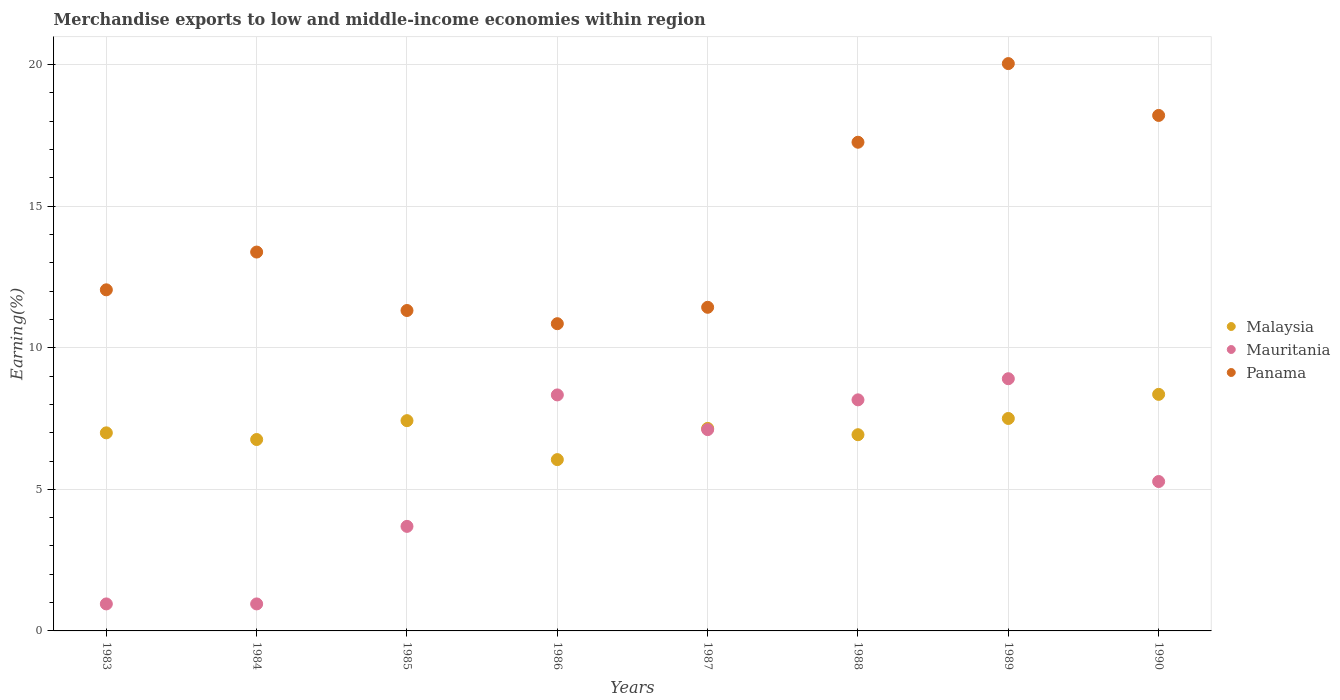How many different coloured dotlines are there?
Offer a very short reply. 3. What is the percentage of amount earned from merchandise exports in Panama in 1985?
Offer a terse response. 11.32. Across all years, what is the maximum percentage of amount earned from merchandise exports in Mauritania?
Your response must be concise. 8.91. Across all years, what is the minimum percentage of amount earned from merchandise exports in Malaysia?
Your response must be concise. 6.05. In which year was the percentage of amount earned from merchandise exports in Malaysia maximum?
Your answer should be compact. 1990. What is the total percentage of amount earned from merchandise exports in Malaysia in the graph?
Provide a short and direct response. 57.17. What is the difference between the percentage of amount earned from merchandise exports in Mauritania in 1983 and that in 1985?
Keep it short and to the point. -2.74. What is the difference between the percentage of amount earned from merchandise exports in Malaysia in 1985 and the percentage of amount earned from merchandise exports in Mauritania in 1989?
Your answer should be compact. -1.48. What is the average percentage of amount earned from merchandise exports in Malaysia per year?
Give a very brief answer. 7.15. In the year 1986, what is the difference between the percentage of amount earned from merchandise exports in Mauritania and percentage of amount earned from merchandise exports in Panama?
Provide a short and direct response. -2.52. What is the ratio of the percentage of amount earned from merchandise exports in Mauritania in 1983 to that in 1984?
Your response must be concise. 1. Is the difference between the percentage of amount earned from merchandise exports in Mauritania in 1984 and 1988 greater than the difference between the percentage of amount earned from merchandise exports in Panama in 1984 and 1988?
Make the answer very short. No. What is the difference between the highest and the second highest percentage of amount earned from merchandise exports in Panama?
Offer a very short reply. 1.83. What is the difference between the highest and the lowest percentage of amount earned from merchandise exports in Panama?
Offer a terse response. 9.19. Is the sum of the percentage of amount earned from merchandise exports in Malaysia in 1983 and 1990 greater than the maximum percentage of amount earned from merchandise exports in Panama across all years?
Provide a short and direct response. No. Is it the case that in every year, the sum of the percentage of amount earned from merchandise exports in Malaysia and percentage of amount earned from merchandise exports in Mauritania  is greater than the percentage of amount earned from merchandise exports in Panama?
Make the answer very short. No. Does the percentage of amount earned from merchandise exports in Malaysia monotonically increase over the years?
Offer a terse response. No. Is the percentage of amount earned from merchandise exports in Malaysia strictly greater than the percentage of amount earned from merchandise exports in Panama over the years?
Offer a terse response. No. What is the difference between two consecutive major ticks on the Y-axis?
Keep it short and to the point. 5. Are the values on the major ticks of Y-axis written in scientific E-notation?
Provide a short and direct response. No. Does the graph contain grids?
Your answer should be very brief. Yes. How many legend labels are there?
Ensure brevity in your answer.  3. How are the legend labels stacked?
Keep it short and to the point. Vertical. What is the title of the graph?
Keep it short and to the point. Merchandise exports to low and middle-income economies within region. Does "Micronesia" appear as one of the legend labels in the graph?
Offer a very short reply. No. What is the label or title of the X-axis?
Your answer should be very brief. Years. What is the label or title of the Y-axis?
Make the answer very short. Earning(%). What is the Earning(%) of Malaysia in 1983?
Keep it short and to the point. 7. What is the Earning(%) in Mauritania in 1983?
Provide a short and direct response. 0.95. What is the Earning(%) of Panama in 1983?
Your answer should be compact. 12.05. What is the Earning(%) in Malaysia in 1984?
Your answer should be compact. 6.76. What is the Earning(%) in Mauritania in 1984?
Provide a short and direct response. 0.95. What is the Earning(%) of Panama in 1984?
Offer a terse response. 13.38. What is the Earning(%) of Malaysia in 1985?
Provide a short and direct response. 7.43. What is the Earning(%) in Mauritania in 1985?
Give a very brief answer. 3.69. What is the Earning(%) of Panama in 1985?
Make the answer very short. 11.32. What is the Earning(%) of Malaysia in 1986?
Provide a succinct answer. 6.05. What is the Earning(%) of Mauritania in 1986?
Provide a short and direct response. 8.33. What is the Earning(%) in Panama in 1986?
Provide a succinct answer. 10.85. What is the Earning(%) in Malaysia in 1987?
Your answer should be compact. 7.15. What is the Earning(%) of Mauritania in 1987?
Offer a terse response. 7.11. What is the Earning(%) in Panama in 1987?
Make the answer very short. 11.43. What is the Earning(%) of Malaysia in 1988?
Make the answer very short. 6.93. What is the Earning(%) in Mauritania in 1988?
Offer a very short reply. 8.16. What is the Earning(%) of Panama in 1988?
Provide a succinct answer. 17.26. What is the Earning(%) in Malaysia in 1989?
Your response must be concise. 7.5. What is the Earning(%) of Mauritania in 1989?
Offer a very short reply. 8.91. What is the Earning(%) of Panama in 1989?
Provide a short and direct response. 20.04. What is the Earning(%) in Malaysia in 1990?
Keep it short and to the point. 8.35. What is the Earning(%) of Mauritania in 1990?
Keep it short and to the point. 5.28. What is the Earning(%) in Panama in 1990?
Keep it short and to the point. 18.2. Across all years, what is the maximum Earning(%) of Malaysia?
Keep it short and to the point. 8.35. Across all years, what is the maximum Earning(%) in Mauritania?
Keep it short and to the point. 8.91. Across all years, what is the maximum Earning(%) in Panama?
Ensure brevity in your answer.  20.04. Across all years, what is the minimum Earning(%) in Malaysia?
Provide a succinct answer. 6.05. Across all years, what is the minimum Earning(%) of Mauritania?
Give a very brief answer. 0.95. Across all years, what is the minimum Earning(%) of Panama?
Your answer should be compact. 10.85. What is the total Earning(%) in Malaysia in the graph?
Provide a succinct answer. 57.17. What is the total Earning(%) in Mauritania in the graph?
Provide a short and direct response. 43.39. What is the total Earning(%) in Panama in the graph?
Provide a succinct answer. 114.52. What is the difference between the Earning(%) in Malaysia in 1983 and that in 1984?
Offer a terse response. 0.24. What is the difference between the Earning(%) of Panama in 1983 and that in 1984?
Offer a very short reply. -1.33. What is the difference between the Earning(%) in Malaysia in 1983 and that in 1985?
Keep it short and to the point. -0.43. What is the difference between the Earning(%) of Mauritania in 1983 and that in 1985?
Your response must be concise. -2.74. What is the difference between the Earning(%) in Panama in 1983 and that in 1985?
Make the answer very short. 0.73. What is the difference between the Earning(%) of Malaysia in 1983 and that in 1986?
Keep it short and to the point. 0.95. What is the difference between the Earning(%) in Mauritania in 1983 and that in 1986?
Offer a terse response. -7.38. What is the difference between the Earning(%) of Panama in 1983 and that in 1986?
Ensure brevity in your answer.  1.2. What is the difference between the Earning(%) of Malaysia in 1983 and that in 1987?
Make the answer very short. -0.16. What is the difference between the Earning(%) of Mauritania in 1983 and that in 1987?
Your answer should be very brief. -6.16. What is the difference between the Earning(%) in Panama in 1983 and that in 1987?
Offer a very short reply. 0.62. What is the difference between the Earning(%) in Malaysia in 1983 and that in 1988?
Your response must be concise. 0.07. What is the difference between the Earning(%) of Mauritania in 1983 and that in 1988?
Offer a terse response. -7.21. What is the difference between the Earning(%) in Panama in 1983 and that in 1988?
Make the answer very short. -5.21. What is the difference between the Earning(%) of Malaysia in 1983 and that in 1989?
Ensure brevity in your answer.  -0.51. What is the difference between the Earning(%) of Mauritania in 1983 and that in 1989?
Your answer should be very brief. -7.95. What is the difference between the Earning(%) in Panama in 1983 and that in 1989?
Provide a succinct answer. -7.99. What is the difference between the Earning(%) of Malaysia in 1983 and that in 1990?
Give a very brief answer. -1.36. What is the difference between the Earning(%) of Mauritania in 1983 and that in 1990?
Your response must be concise. -4.32. What is the difference between the Earning(%) of Panama in 1983 and that in 1990?
Your response must be concise. -6.16. What is the difference between the Earning(%) in Malaysia in 1984 and that in 1985?
Ensure brevity in your answer.  -0.67. What is the difference between the Earning(%) of Mauritania in 1984 and that in 1985?
Ensure brevity in your answer.  -2.74. What is the difference between the Earning(%) in Panama in 1984 and that in 1985?
Provide a succinct answer. 2.06. What is the difference between the Earning(%) of Malaysia in 1984 and that in 1986?
Offer a terse response. 0.71. What is the difference between the Earning(%) in Mauritania in 1984 and that in 1986?
Your answer should be compact. -7.38. What is the difference between the Earning(%) of Panama in 1984 and that in 1986?
Your answer should be compact. 2.53. What is the difference between the Earning(%) of Malaysia in 1984 and that in 1987?
Give a very brief answer. -0.39. What is the difference between the Earning(%) of Mauritania in 1984 and that in 1987?
Provide a short and direct response. -6.16. What is the difference between the Earning(%) in Panama in 1984 and that in 1987?
Your answer should be compact. 1.95. What is the difference between the Earning(%) in Malaysia in 1984 and that in 1988?
Give a very brief answer. -0.17. What is the difference between the Earning(%) in Mauritania in 1984 and that in 1988?
Keep it short and to the point. -7.21. What is the difference between the Earning(%) in Panama in 1984 and that in 1988?
Your answer should be very brief. -3.88. What is the difference between the Earning(%) in Malaysia in 1984 and that in 1989?
Provide a succinct answer. -0.74. What is the difference between the Earning(%) of Mauritania in 1984 and that in 1989?
Your answer should be compact. -7.95. What is the difference between the Earning(%) in Panama in 1984 and that in 1989?
Offer a terse response. -6.66. What is the difference between the Earning(%) of Malaysia in 1984 and that in 1990?
Offer a very short reply. -1.59. What is the difference between the Earning(%) of Mauritania in 1984 and that in 1990?
Provide a short and direct response. -4.32. What is the difference between the Earning(%) in Panama in 1984 and that in 1990?
Provide a short and direct response. -4.83. What is the difference between the Earning(%) of Malaysia in 1985 and that in 1986?
Give a very brief answer. 1.38. What is the difference between the Earning(%) in Mauritania in 1985 and that in 1986?
Offer a very short reply. -4.64. What is the difference between the Earning(%) in Panama in 1985 and that in 1986?
Offer a very short reply. 0.47. What is the difference between the Earning(%) of Malaysia in 1985 and that in 1987?
Make the answer very short. 0.27. What is the difference between the Earning(%) of Mauritania in 1985 and that in 1987?
Provide a succinct answer. -3.42. What is the difference between the Earning(%) in Panama in 1985 and that in 1987?
Your response must be concise. -0.11. What is the difference between the Earning(%) of Malaysia in 1985 and that in 1988?
Give a very brief answer. 0.5. What is the difference between the Earning(%) of Mauritania in 1985 and that in 1988?
Provide a succinct answer. -4.47. What is the difference between the Earning(%) of Panama in 1985 and that in 1988?
Ensure brevity in your answer.  -5.94. What is the difference between the Earning(%) of Malaysia in 1985 and that in 1989?
Keep it short and to the point. -0.08. What is the difference between the Earning(%) of Mauritania in 1985 and that in 1989?
Ensure brevity in your answer.  -5.21. What is the difference between the Earning(%) of Panama in 1985 and that in 1989?
Provide a short and direct response. -8.72. What is the difference between the Earning(%) of Malaysia in 1985 and that in 1990?
Offer a terse response. -0.93. What is the difference between the Earning(%) in Mauritania in 1985 and that in 1990?
Ensure brevity in your answer.  -1.58. What is the difference between the Earning(%) in Panama in 1985 and that in 1990?
Provide a short and direct response. -6.89. What is the difference between the Earning(%) in Malaysia in 1986 and that in 1987?
Provide a short and direct response. -1.1. What is the difference between the Earning(%) in Mauritania in 1986 and that in 1987?
Offer a terse response. 1.23. What is the difference between the Earning(%) of Panama in 1986 and that in 1987?
Your response must be concise. -0.58. What is the difference between the Earning(%) of Malaysia in 1986 and that in 1988?
Offer a very short reply. -0.88. What is the difference between the Earning(%) of Mauritania in 1986 and that in 1988?
Offer a very short reply. 0.17. What is the difference between the Earning(%) in Panama in 1986 and that in 1988?
Offer a very short reply. -6.41. What is the difference between the Earning(%) of Malaysia in 1986 and that in 1989?
Make the answer very short. -1.45. What is the difference between the Earning(%) in Mauritania in 1986 and that in 1989?
Offer a very short reply. -0.57. What is the difference between the Earning(%) of Panama in 1986 and that in 1989?
Give a very brief answer. -9.19. What is the difference between the Earning(%) in Malaysia in 1986 and that in 1990?
Make the answer very short. -2.3. What is the difference between the Earning(%) of Mauritania in 1986 and that in 1990?
Ensure brevity in your answer.  3.06. What is the difference between the Earning(%) in Panama in 1986 and that in 1990?
Your answer should be very brief. -7.36. What is the difference between the Earning(%) of Malaysia in 1987 and that in 1988?
Offer a terse response. 0.22. What is the difference between the Earning(%) in Mauritania in 1987 and that in 1988?
Make the answer very short. -1.05. What is the difference between the Earning(%) in Panama in 1987 and that in 1988?
Keep it short and to the point. -5.83. What is the difference between the Earning(%) in Malaysia in 1987 and that in 1989?
Give a very brief answer. -0.35. What is the difference between the Earning(%) in Mauritania in 1987 and that in 1989?
Give a very brief answer. -1.8. What is the difference between the Earning(%) in Panama in 1987 and that in 1989?
Provide a succinct answer. -8.61. What is the difference between the Earning(%) of Malaysia in 1987 and that in 1990?
Keep it short and to the point. -1.2. What is the difference between the Earning(%) in Mauritania in 1987 and that in 1990?
Offer a terse response. 1.83. What is the difference between the Earning(%) in Panama in 1987 and that in 1990?
Offer a very short reply. -6.78. What is the difference between the Earning(%) in Malaysia in 1988 and that in 1989?
Offer a terse response. -0.57. What is the difference between the Earning(%) of Mauritania in 1988 and that in 1989?
Provide a succinct answer. -0.75. What is the difference between the Earning(%) in Panama in 1988 and that in 1989?
Make the answer very short. -2.78. What is the difference between the Earning(%) in Malaysia in 1988 and that in 1990?
Provide a short and direct response. -1.42. What is the difference between the Earning(%) in Mauritania in 1988 and that in 1990?
Provide a succinct answer. 2.88. What is the difference between the Earning(%) of Panama in 1988 and that in 1990?
Give a very brief answer. -0.95. What is the difference between the Earning(%) in Malaysia in 1989 and that in 1990?
Make the answer very short. -0.85. What is the difference between the Earning(%) in Mauritania in 1989 and that in 1990?
Your answer should be very brief. 3.63. What is the difference between the Earning(%) in Panama in 1989 and that in 1990?
Your answer should be compact. 1.83. What is the difference between the Earning(%) in Malaysia in 1983 and the Earning(%) in Mauritania in 1984?
Your answer should be compact. 6.04. What is the difference between the Earning(%) of Malaysia in 1983 and the Earning(%) of Panama in 1984?
Offer a very short reply. -6.38. What is the difference between the Earning(%) in Mauritania in 1983 and the Earning(%) in Panama in 1984?
Make the answer very short. -12.43. What is the difference between the Earning(%) in Malaysia in 1983 and the Earning(%) in Mauritania in 1985?
Your answer should be very brief. 3.3. What is the difference between the Earning(%) of Malaysia in 1983 and the Earning(%) of Panama in 1985?
Offer a very short reply. -4.32. What is the difference between the Earning(%) of Mauritania in 1983 and the Earning(%) of Panama in 1985?
Provide a short and direct response. -10.36. What is the difference between the Earning(%) in Malaysia in 1983 and the Earning(%) in Mauritania in 1986?
Offer a very short reply. -1.34. What is the difference between the Earning(%) in Malaysia in 1983 and the Earning(%) in Panama in 1986?
Make the answer very short. -3.85. What is the difference between the Earning(%) of Mauritania in 1983 and the Earning(%) of Panama in 1986?
Your response must be concise. -9.9. What is the difference between the Earning(%) of Malaysia in 1983 and the Earning(%) of Mauritania in 1987?
Your answer should be very brief. -0.11. What is the difference between the Earning(%) of Malaysia in 1983 and the Earning(%) of Panama in 1987?
Your answer should be compact. -4.43. What is the difference between the Earning(%) of Mauritania in 1983 and the Earning(%) of Panama in 1987?
Offer a terse response. -10.48. What is the difference between the Earning(%) in Malaysia in 1983 and the Earning(%) in Mauritania in 1988?
Give a very brief answer. -1.17. What is the difference between the Earning(%) in Malaysia in 1983 and the Earning(%) in Panama in 1988?
Ensure brevity in your answer.  -10.26. What is the difference between the Earning(%) in Mauritania in 1983 and the Earning(%) in Panama in 1988?
Offer a terse response. -16.3. What is the difference between the Earning(%) in Malaysia in 1983 and the Earning(%) in Mauritania in 1989?
Provide a succinct answer. -1.91. What is the difference between the Earning(%) of Malaysia in 1983 and the Earning(%) of Panama in 1989?
Offer a very short reply. -13.04. What is the difference between the Earning(%) of Mauritania in 1983 and the Earning(%) of Panama in 1989?
Make the answer very short. -19.08. What is the difference between the Earning(%) of Malaysia in 1983 and the Earning(%) of Mauritania in 1990?
Your response must be concise. 1.72. What is the difference between the Earning(%) in Malaysia in 1983 and the Earning(%) in Panama in 1990?
Offer a terse response. -11.21. What is the difference between the Earning(%) of Mauritania in 1983 and the Earning(%) of Panama in 1990?
Your answer should be very brief. -17.25. What is the difference between the Earning(%) of Malaysia in 1984 and the Earning(%) of Mauritania in 1985?
Give a very brief answer. 3.07. What is the difference between the Earning(%) in Malaysia in 1984 and the Earning(%) in Panama in 1985?
Offer a terse response. -4.56. What is the difference between the Earning(%) of Mauritania in 1984 and the Earning(%) of Panama in 1985?
Offer a very short reply. -10.36. What is the difference between the Earning(%) in Malaysia in 1984 and the Earning(%) in Mauritania in 1986?
Ensure brevity in your answer.  -1.58. What is the difference between the Earning(%) in Malaysia in 1984 and the Earning(%) in Panama in 1986?
Provide a short and direct response. -4.09. What is the difference between the Earning(%) in Mauritania in 1984 and the Earning(%) in Panama in 1986?
Your answer should be very brief. -9.9. What is the difference between the Earning(%) in Malaysia in 1984 and the Earning(%) in Mauritania in 1987?
Your answer should be very brief. -0.35. What is the difference between the Earning(%) of Malaysia in 1984 and the Earning(%) of Panama in 1987?
Your response must be concise. -4.67. What is the difference between the Earning(%) of Mauritania in 1984 and the Earning(%) of Panama in 1987?
Provide a succinct answer. -10.48. What is the difference between the Earning(%) of Malaysia in 1984 and the Earning(%) of Mauritania in 1988?
Make the answer very short. -1.4. What is the difference between the Earning(%) of Malaysia in 1984 and the Earning(%) of Panama in 1988?
Provide a short and direct response. -10.5. What is the difference between the Earning(%) of Mauritania in 1984 and the Earning(%) of Panama in 1988?
Give a very brief answer. -16.3. What is the difference between the Earning(%) in Malaysia in 1984 and the Earning(%) in Mauritania in 1989?
Offer a very short reply. -2.15. What is the difference between the Earning(%) in Malaysia in 1984 and the Earning(%) in Panama in 1989?
Keep it short and to the point. -13.28. What is the difference between the Earning(%) in Mauritania in 1984 and the Earning(%) in Panama in 1989?
Give a very brief answer. -19.08. What is the difference between the Earning(%) of Malaysia in 1984 and the Earning(%) of Mauritania in 1990?
Offer a terse response. 1.48. What is the difference between the Earning(%) of Malaysia in 1984 and the Earning(%) of Panama in 1990?
Make the answer very short. -11.45. What is the difference between the Earning(%) of Mauritania in 1984 and the Earning(%) of Panama in 1990?
Offer a terse response. -17.25. What is the difference between the Earning(%) of Malaysia in 1985 and the Earning(%) of Mauritania in 1986?
Provide a succinct answer. -0.91. What is the difference between the Earning(%) in Malaysia in 1985 and the Earning(%) in Panama in 1986?
Offer a terse response. -3.42. What is the difference between the Earning(%) of Mauritania in 1985 and the Earning(%) of Panama in 1986?
Offer a very short reply. -7.16. What is the difference between the Earning(%) in Malaysia in 1985 and the Earning(%) in Mauritania in 1987?
Your answer should be compact. 0.32. What is the difference between the Earning(%) of Malaysia in 1985 and the Earning(%) of Panama in 1987?
Provide a succinct answer. -4. What is the difference between the Earning(%) of Mauritania in 1985 and the Earning(%) of Panama in 1987?
Your answer should be compact. -7.74. What is the difference between the Earning(%) in Malaysia in 1985 and the Earning(%) in Mauritania in 1988?
Provide a short and direct response. -0.73. What is the difference between the Earning(%) in Malaysia in 1985 and the Earning(%) in Panama in 1988?
Provide a short and direct response. -9.83. What is the difference between the Earning(%) in Mauritania in 1985 and the Earning(%) in Panama in 1988?
Your response must be concise. -13.57. What is the difference between the Earning(%) of Malaysia in 1985 and the Earning(%) of Mauritania in 1989?
Keep it short and to the point. -1.48. What is the difference between the Earning(%) of Malaysia in 1985 and the Earning(%) of Panama in 1989?
Keep it short and to the point. -12.61. What is the difference between the Earning(%) of Mauritania in 1985 and the Earning(%) of Panama in 1989?
Give a very brief answer. -16.34. What is the difference between the Earning(%) of Malaysia in 1985 and the Earning(%) of Mauritania in 1990?
Provide a short and direct response. 2.15. What is the difference between the Earning(%) in Malaysia in 1985 and the Earning(%) in Panama in 1990?
Your answer should be compact. -10.78. What is the difference between the Earning(%) in Mauritania in 1985 and the Earning(%) in Panama in 1990?
Ensure brevity in your answer.  -14.51. What is the difference between the Earning(%) of Malaysia in 1986 and the Earning(%) of Mauritania in 1987?
Give a very brief answer. -1.06. What is the difference between the Earning(%) in Malaysia in 1986 and the Earning(%) in Panama in 1987?
Ensure brevity in your answer.  -5.38. What is the difference between the Earning(%) in Mauritania in 1986 and the Earning(%) in Panama in 1987?
Your answer should be compact. -3.09. What is the difference between the Earning(%) in Malaysia in 1986 and the Earning(%) in Mauritania in 1988?
Offer a very short reply. -2.11. What is the difference between the Earning(%) of Malaysia in 1986 and the Earning(%) of Panama in 1988?
Your answer should be compact. -11.21. What is the difference between the Earning(%) of Mauritania in 1986 and the Earning(%) of Panama in 1988?
Provide a short and direct response. -8.92. What is the difference between the Earning(%) in Malaysia in 1986 and the Earning(%) in Mauritania in 1989?
Offer a very short reply. -2.86. What is the difference between the Earning(%) of Malaysia in 1986 and the Earning(%) of Panama in 1989?
Your response must be concise. -13.99. What is the difference between the Earning(%) in Mauritania in 1986 and the Earning(%) in Panama in 1989?
Offer a terse response. -11.7. What is the difference between the Earning(%) in Malaysia in 1986 and the Earning(%) in Mauritania in 1990?
Ensure brevity in your answer.  0.77. What is the difference between the Earning(%) in Malaysia in 1986 and the Earning(%) in Panama in 1990?
Offer a terse response. -12.16. What is the difference between the Earning(%) in Mauritania in 1986 and the Earning(%) in Panama in 1990?
Your response must be concise. -9.87. What is the difference between the Earning(%) of Malaysia in 1987 and the Earning(%) of Mauritania in 1988?
Your answer should be compact. -1.01. What is the difference between the Earning(%) in Malaysia in 1987 and the Earning(%) in Panama in 1988?
Make the answer very short. -10.11. What is the difference between the Earning(%) in Mauritania in 1987 and the Earning(%) in Panama in 1988?
Provide a succinct answer. -10.15. What is the difference between the Earning(%) in Malaysia in 1987 and the Earning(%) in Mauritania in 1989?
Make the answer very short. -1.75. What is the difference between the Earning(%) in Malaysia in 1987 and the Earning(%) in Panama in 1989?
Your response must be concise. -12.88. What is the difference between the Earning(%) of Mauritania in 1987 and the Earning(%) of Panama in 1989?
Ensure brevity in your answer.  -12.93. What is the difference between the Earning(%) in Malaysia in 1987 and the Earning(%) in Mauritania in 1990?
Your answer should be compact. 1.88. What is the difference between the Earning(%) in Malaysia in 1987 and the Earning(%) in Panama in 1990?
Offer a very short reply. -11.05. What is the difference between the Earning(%) in Mauritania in 1987 and the Earning(%) in Panama in 1990?
Offer a terse response. -11.1. What is the difference between the Earning(%) in Malaysia in 1988 and the Earning(%) in Mauritania in 1989?
Your answer should be very brief. -1.98. What is the difference between the Earning(%) in Malaysia in 1988 and the Earning(%) in Panama in 1989?
Your answer should be very brief. -13.11. What is the difference between the Earning(%) of Mauritania in 1988 and the Earning(%) of Panama in 1989?
Give a very brief answer. -11.88. What is the difference between the Earning(%) in Malaysia in 1988 and the Earning(%) in Mauritania in 1990?
Ensure brevity in your answer.  1.65. What is the difference between the Earning(%) of Malaysia in 1988 and the Earning(%) of Panama in 1990?
Provide a succinct answer. -11.28. What is the difference between the Earning(%) in Mauritania in 1988 and the Earning(%) in Panama in 1990?
Provide a succinct answer. -10.04. What is the difference between the Earning(%) in Malaysia in 1989 and the Earning(%) in Mauritania in 1990?
Your answer should be very brief. 2.23. What is the difference between the Earning(%) of Malaysia in 1989 and the Earning(%) of Panama in 1990?
Provide a succinct answer. -10.7. What is the difference between the Earning(%) of Mauritania in 1989 and the Earning(%) of Panama in 1990?
Make the answer very short. -9.3. What is the average Earning(%) in Malaysia per year?
Your answer should be very brief. 7.15. What is the average Earning(%) in Mauritania per year?
Ensure brevity in your answer.  5.42. What is the average Earning(%) in Panama per year?
Ensure brevity in your answer.  14.31. In the year 1983, what is the difference between the Earning(%) in Malaysia and Earning(%) in Mauritania?
Provide a short and direct response. 6.04. In the year 1983, what is the difference between the Earning(%) in Malaysia and Earning(%) in Panama?
Offer a terse response. -5.05. In the year 1983, what is the difference between the Earning(%) of Mauritania and Earning(%) of Panama?
Give a very brief answer. -11.09. In the year 1984, what is the difference between the Earning(%) in Malaysia and Earning(%) in Mauritania?
Your response must be concise. 5.81. In the year 1984, what is the difference between the Earning(%) in Malaysia and Earning(%) in Panama?
Provide a short and direct response. -6.62. In the year 1984, what is the difference between the Earning(%) of Mauritania and Earning(%) of Panama?
Make the answer very short. -12.43. In the year 1985, what is the difference between the Earning(%) in Malaysia and Earning(%) in Mauritania?
Your answer should be very brief. 3.73. In the year 1985, what is the difference between the Earning(%) in Malaysia and Earning(%) in Panama?
Your answer should be very brief. -3.89. In the year 1985, what is the difference between the Earning(%) in Mauritania and Earning(%) in Panama?
Make the answer very short. -7.62. In the year 1986, what is the difference between the Earning(%) in Malaysia and Earning(%) in Mauritania?
Offer a terse response. -2.28. In the year 1986, what is the difference between the Earning(%) in Malaysia and Earning(%) in Panama?
Make the answer very short. -4.8. In the year 1986, what is the difference between the Earning(%) of Mauritania and Earning(%) of Panama?
Keep it short and to the point. -2.52. In the year 1987, what is the difference between the Earning(%) in Malaysia and Earning(%) in Mauritania?
Provide a succinct answer. 0.04. In the year 1987, what is the difference between the Earning(%) of Malaysia and Earning(%) of Panama?
Your answer should be very brief. -4.28. In the year 1987, what is the difference between the Earning(%) of Mauritania and Earning(%) of Panama?
Offer a terse response. -4.32. In the year 1988, what is the difference between the Earning(%) in Malaysia and Earning(%) in Mauritania?
Make the answer very short. -1.23. In the year 1988, what is the difference between the Earning(%) in Malaysia and Earning(%) in Panama?
Offer a terse response. -10.33. In the year 1988, what is the difference between the Earning(%) of Mauritania and Earning(%) of Panama?
Make the answer very short. -9.1. In the year 1989, what is the difference between the Earning(%) in Malaysia and Earning(%) in Mauritania?
Give a very brief answer. -1.4. In the year 1989, what is the difference between the Earning(%) in Malaysia and Earning(%) in Panama?
Your answer should be compact. -12.53. In the year 1989, what is the difference between the Earning(%) of Mauritania and Earning(%) of Panama?
Offer a terse response. -11.13. In the year 1990, what is the difference between the Earning(%) in Malaysia and Earning(%) in Mauritania?
Keep it short and to the point. 3.08. In the year 1990, what is the difference between the Earning(%) in Malaysia and Earning(%) in Panama?
Your answer should be very brief. -9.85. In the year 1990, what is the difference between the Earning(%) in Mauritania and Earning(%) in Panama?
Give a very brief answer. -12.93. What is the ratio of the Earning(%) of Malaysia in 1983 to that in 1984?
Your answer should be compact. 1.03. What is the ratio of the Earning(%) of Panama in 1983 to that in 1984?
Provide a short and direct response. 0.9. What is the ratio of the Earning(%) of Malaysia in 1983 to that in 1985?
Your answer should be compact. 0.94. What is the ratio of the Earning(%) of Mauritania in 1983 to that in 1985?
Your response must be concise. 0.26. What is the ratio of the Earning(%) of Panama in 1983 to that in 1985?
Make the answer very short. 1.06. What is the ratio of the Earning(%) in Malaysia in 1983 to that in 1986?
Your answer should be compact. 1.16. What is the ratio of the Earning(%) in Mauritania in 1983 to that in 1986?
Your response must be concise. 0.11. What is the ratio of the Earning(%) in Panama in 1983 to that in 1986?
Offer a very short reply. 1.11. What is the ratio of the Earning(%) of Malaysia in 1983 to that in 1987?
Your answer should be compact. 0.98. What is the ratio of the Earning(%) in Mauritania in 1983 to that in 1987?
Your answer should be compact. 0.13. What is the ratio of the Earning(%) of Panama in 1983 to that in 1987?
Offer a terse response. 1.05. What is the ratio of the Earning(%) of Malaysia in 1983 to that in 1988?
Offer a very short reply. 1.01. What is the ratio of the Earning(%) of Mauritania in 1983 to that in 1988?
Ensure brevity in your answer.  0.12. What is the ratio of the Earning(%) in Panama in 1983 to that in 1988?
Keep it short and to the point. 0.7. What is the ratio of the Earning(%) in Malaysia in 1983 to that in 1989?
Give a very brief answer. 0.93. What is the ratio of the Earning(%) of Mauritania in 1983 to that in 1989?
Provide a succinct answer. 0.11. What is the ratio of the Earning(%) of Panama in 1983 to that in 1989?
Provide a succinct answer. 0.6. What is the ratio of the Earning(%) of Malaysia in 1983 to that in 1990?
Offer a very short reply. 0.84. What is the ratio of the Earning(%) in Mauritania in 1983 to that in 1990?
Provide a short and direct response. 0.18. What is the ratio of the Earning(%) in Panama in 1983 to that in 1990?
Make the answer very short. 0.66. What is the ratio of the Earning(%) in Malaysia in 1984 to that in 1985?
Offer a terse response. 0.91. What is the ratio of the Earning(%) of Mauritania in 1984 to that in 1985?
Give a very brief answer. 0.26. What is the ratio of the Earning(%) of Panama in 1984 to that in 1985?
Offer a terse response. 1.18. What is the ratio of the Earning(%) of Malaysia in 1984 to that in 1986?
Ensure brevity in your answer.  1.12. What is the ratio of the Earning(%) of Mauritania in 1984 to that in 1986?
Give a very brief answer. 0.11. What is the ratio of the Earning(%) in Panama in 1984 to that in 1986?
Your answer should be compact. 1.23. What is the ratio of the Earning(%) in Malaysia in 1984 to that in 1987?
Keep it short and to the point. 0.95. What is the ratio of the Earning(%) in Mauritania in 1984 to that in 1987?
Offer a very short reply. 0.13. What is the ratio of the Earning(%) in Panama in 1984 to that in 1987?
Offer a very short reply. 1.17. What is the ratio of the Earning(%) of Malaysia in 1984 to that in 1988?
Ensure brevity in your answer.  0.98. What is the ratio of the Earning(%) in Mauritania in 1984 to that in 1988?
Your answer should be very brief. 0.12. What is the ratio of the Earning(%) in Panama in 1984 to that in 1988?
Ensure brevity in your answer.  0.78. What is the ratio of the Earning(%) of Malaysia in 1984 to that in 1989?
Provide a short and direct response. 0.9. What is the ratio of the Earning(%) of Mauritania in 1984 to that in 1989?
Keep it short and to the point. 0.11. What is the ratio of the Earning(%) in Panama in 1984 to that in 1989?
Provide a short and direct response. 0.67. What is the ratio of the Earning(%) in Malaysia in 1984 to that in 1990?
Your answer should be very brief. 0.81. What is the ratio of the Earning(%) in Mauritania in 1984 to that in 1990?
Keep it short and to the point. 0.18. What is the ratio of the Earning(%) in Panama in 1984 to that in 1990?
Your answer should be very brief. 0.73. What is the ratio of the Earning(%) in Malaysia in 1985 to that in 1986?
Ensure brevity in your answer.  1.23. What is the ratio of the Earning(%) in Mauritania in 1985 to that in 1986?
Your answer should be compact. 0.44. What is the ratio of the Earning(%) in Panama in 1985 to that in 1986?
Provide a short and direct response. 1.04. What is the ratio of the Earning(%) of Malaysia in 1985 to that in 1987?
Your answer should be very brief. 1.04. What is the ratio of the Earning(%) in Mauritania in 1985 to that in 1987?
Give a very brief answer. 0.52. What is the ratio of the Earning(%) in Panama in 1985 to that in 1987?
Your response must be concise. 0.99. What is the ratio of the Earning(%) in Malaysia in 1985 to that in 1988?
Your response must be concise. 1.07. What is the ratio of the Earning(%) in Mauritania in 1985 to that in 1988?
Ensure brevity in your answer.  0.45. What is the ratio of the Earning(%) in Panama in 1985 to that in 1988?
Make the answer very short. 0.66. What is the ratio of the Earning(%) of Malaysia in 1985 to that in 1989?
Offer a very short reply. 0.99. What is the ratio of the Earning(%) in Mauritania in 1985 to that in 1989?
Your answer should be very brief. 0.41. What is the ratio of the Earning(%) of Panama in 1985 to that in 1989?
Give a very brief answer. 0.56. What is the ratio of the Earning(%) of Mauritania in 1985 to that in 1990?
Keep it short and to the point. 0.7. What is the ratio of the Earning(%) of Panama in 1985 to that in 1990?
Keep it short and to the point. 0.62. What is the ratio of the Earning(%) in Malaysia in 1986 to that in 1987?
Provide a short and direct response. 0.85. What is the ratio of the Earning(%) of Mauritania in 1986 to that in 1987?
Offer a very short reply. 1.17. What is the ratio of the Earning(%) in Panama in 1986 to that in 1987?
Provide a short and direct response. 0.95. What is the ratio of the Earning(%) of Malaysia in 1986 to that in 1988?
Offer a terse response. 0.87. What is the ratio of the Earning(%) of Mauritania in 1986 to that in 1988?
Give a very brief answer. 1.02. What is the ratio of the Earning(%) of Panama in 1986 to that in 1988?
Offer a terse response. 0.63. What is the ratio of the Earning(%) of Malaysia in 1986 to that in 1989?
Your answer should be compact. 0.81. What is the ratio of the Earning(%) of Mauritania in 1986 to that in 1989?
Keep it short and to the point. 0.94. What is the ratio of the Earning(%) of Panama in 1986 to that in 1989?
Your response must be concise. 0.54. What is the ratio of the Earning(%) of Malaysia in 1986 to that in 1990?
Your response must be concise. 0.72. What is the ratio of the Earning(%) of Mauritania in 1986 to that in 1990?
Your response must be concise. 1.58. What is the ratio of the Earning(%) of Panama in 1986 to that in 1990?
Provide a short and direct response. 0.6. What is the ratio of the Earning(%) in Malaysia in 1987 to that in 1988?
Offer a terse response. 1.03. What is the ratio of the Earning(%) of Mauritania in 1987 to that in 1988?
Provide a short and direct response. 0.87. What is the ratio of the Earning(%) of Panama in 1987 to that in 1988?
Give a very brief answer. 0.66. What is the ratio of the Earning(%) in Malaysia in 1987 to that in 1989?
Your response must be concise. 0.95. What is the ratio of the Earning(%) of Mauritania in 1987 to that in 1989?
Provide a short and direct response. 0.8. What is the ratio of the Earning(%) of Panama in 1987 to that in 1989?
Your answer should be very brief. 0.57. What is the ratio of the Earning(%) in Malaysia in 1987 to that in 1990?
Make the answer very short. 0.86. What is the ratio of the Earning(%) of Mauritania in 1987 to that in 1990?
Keep it short and to the point. 1.35. What is the ratio of the Earning(%) in Panama in 1987 to that in 1990?
Your answer should be compact. 0.63. What is the ratio of the Earning(%) in Malaysia in 1988 to that in 1989?
Ensure brevity in your answer.  0.92. What is the ratio of the Earning(%) in Mauritania in 1988 to that in 1989?
Offer a terse response. 0.92. What is the ratio of the Earning(%) in Panama in 1988 to that in 1989?
Keep it short and to the point. 0.86. What is the ratio of the Earning(%) in Malaysia in 1988 to that in 1990?
Provide a short and direct response. 0.83. What is the ratio of the Earning(%) in Mauritania in 1988 to that in 1990?
Ensure brevity in your answer.  1.55. What is the ratio of the Earning(%) of Panama in 1988 to that in 1990?
Your response must be concise. 0.95. What is the ratio of the Earning(%) in Malaysia in 1989 to that in 1990?
Provide a succinct answer. 0.9. What is the ratio of the Earning(%) of Mauritania in 1989 to that in 1990?
Give a very brief answer. 1.69. What is the ratio of the Earning(%) in Panama in 1989 to that in 1990?
Ensure brevity in your answer.  1.1. What is the difference between the highest and the second highest Earning(%) of Malaysia?
Make the answer very short. 0.85. What is the difference between the highest and the second highest Earning(%) in Mauritania?
Ensure brevity in your answer.  0.57. What is the difference between the highest and the second highest Earning(%) of Panama?
Your response must be concise. 1.83. What is the difference between the highest and the lowest Earning(%) of Malaysia?
Your answer should be compact. 2.3. What is the difference between the highest and the lowest Earning(%) of Mauritania?
Give a very brief answer. 7.95. What is the difference between the highest and the lowest Earning(%) in Panama?
Ensure brevity in your answer.  9.19. 